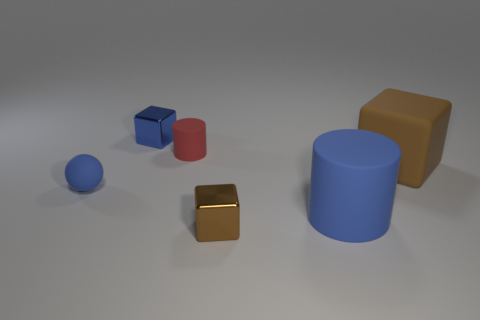There is a tiny thing that is the same color as the big block; what shape is it?
Offer a terse response. Cube. What number of things are right of the small metal block that is to the right of the shiny cube behind the tiny brown metal block?
Provide a short and direct response. 2. There is a rubber thing that is the same size as the blue sphere; what color is it?
Make the answer very short. Red. How many other objects are there of the same color as the big rubber cylinder?
Provide a short and direct response. 2. Is the number of big rubber objects behind the large blue object greater than the number of big blue rubber blocks?
Keep it short and to the point. Yes. Do the ball and the small cylinder have the same material?
Your answer should be compact. Yes. What number of things are small blocks on the left side of the small red rubber cylinder or large cyan matte balls?
Provide a succinct answer. 1. How many other things are the same size as the red rubber cylinder?
Offer a very short reply. 3. Are there the same number of small brown metal cubes behind the big brown rubber object and small blocks in front of the red cylinder?
Ensure brevity in your answer.  No. What color is the other matte object that is the same shape as the tiny red rubber thing?
Your answer should be very brief. Blue. 